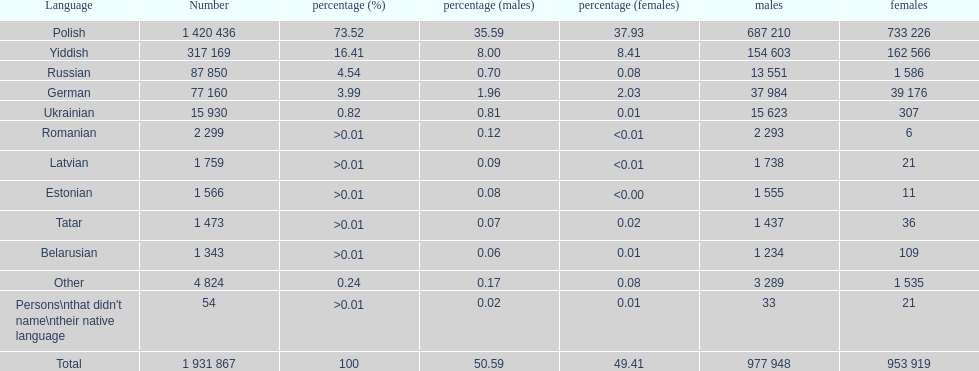Number of male russian speakers 13 551. 